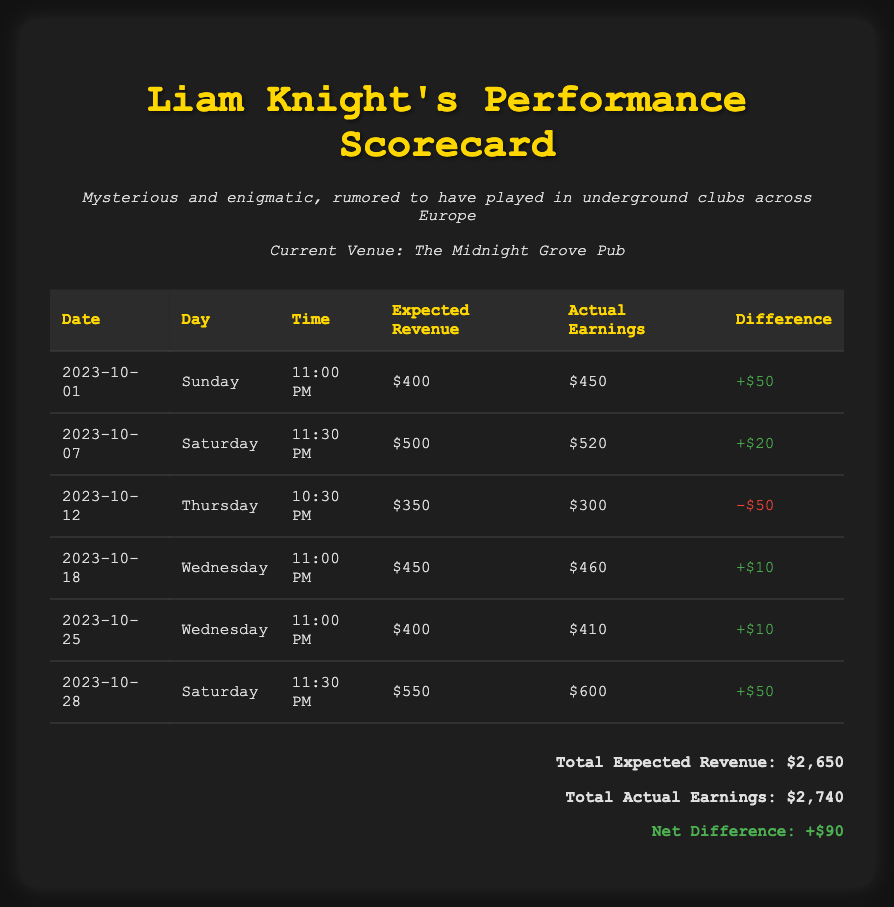What is the total expected revenue for the month? The total expected revenue is the sum of expected revenues from all performances in the document, which is $400 + $500 + $350 + $450 + $400 + $550 = $2,650.
Answer: $2,650 What was the actual earnings on October 12th? The actual earnings on October 12th are recorded in the table for that date, which shows actual earnings of $300.
Answer: $300 How many performances were expected to earn $400 or more? By reviewing the expected revenue values in the table, there are four performances of $400 or more: $400, $500, $450, and $550.
Answer: 4 What is the net difference between expected revenue and actual earnings? The net difference is calculated as total actual earnings minus total expected revenue, which is $2,740 - $2,650 = $90.
Answer: $90 Which day had the highest expected revenue? The highest expected revenue can be found by scanning through the expected revenue values, identifying that Saturday, October 28th had the highest at $550.
Answer: $550 What day came after the lowest actual earning performance? The lowest actual earning recorded was on October 12th, which was a Thursday; the following day in the performance schedule is Wednesday, October 18th.
Answer: Wednesday How many days were performances on a Saturday? The document lists two days for performances that are Saturdays: October 7th and October 28th.
Answer: 2 What is the highest actual earning recorded? The highest actual earning is found by reviewing the actual earnings column in the table, which indicates that October 28th had the highest at $600.
Answer: $600 